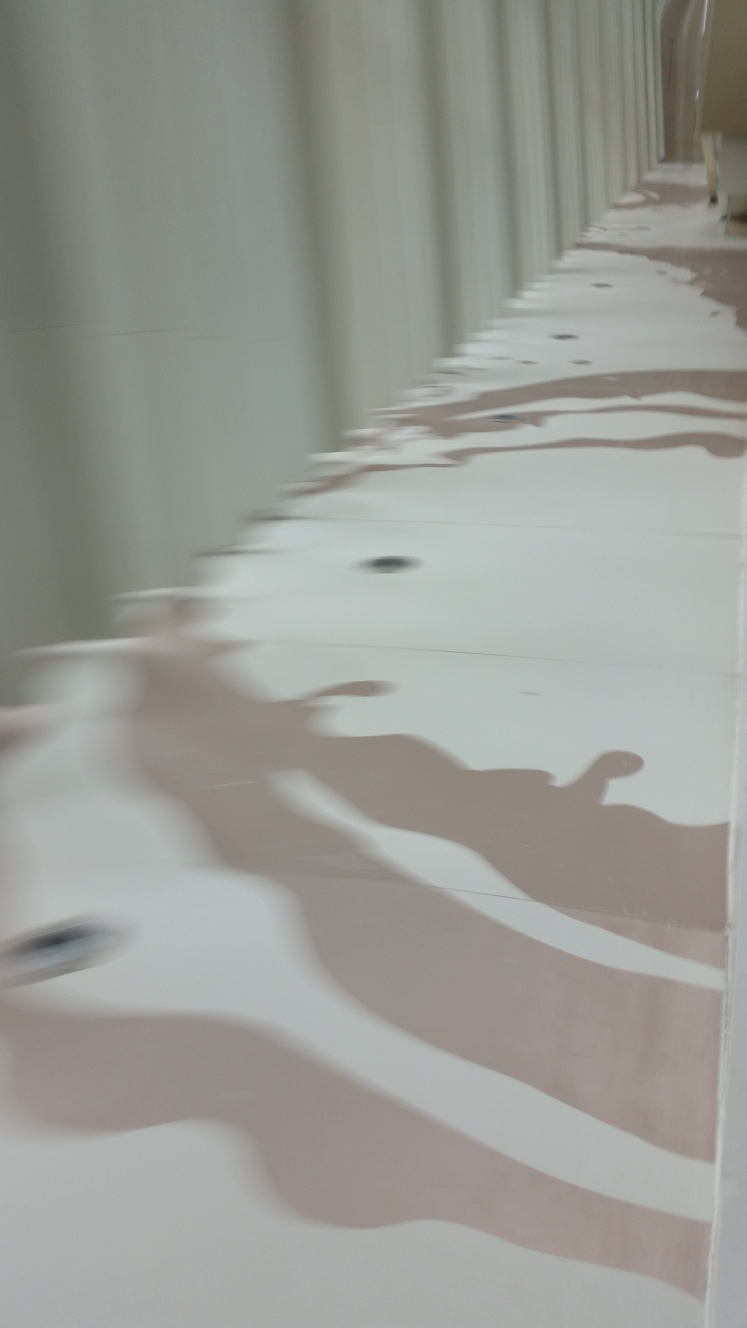Can you describe what you think this structure might be used for? From the visual cues, it looks like an interior space with curved walls, possibly a corridor or part of a modern architectural structure. The wavy reflections on the surfaces suggest that it might be designed to create a sense of movement or fluidity, possibly in a gallery or a transit area within a contemporary building. 